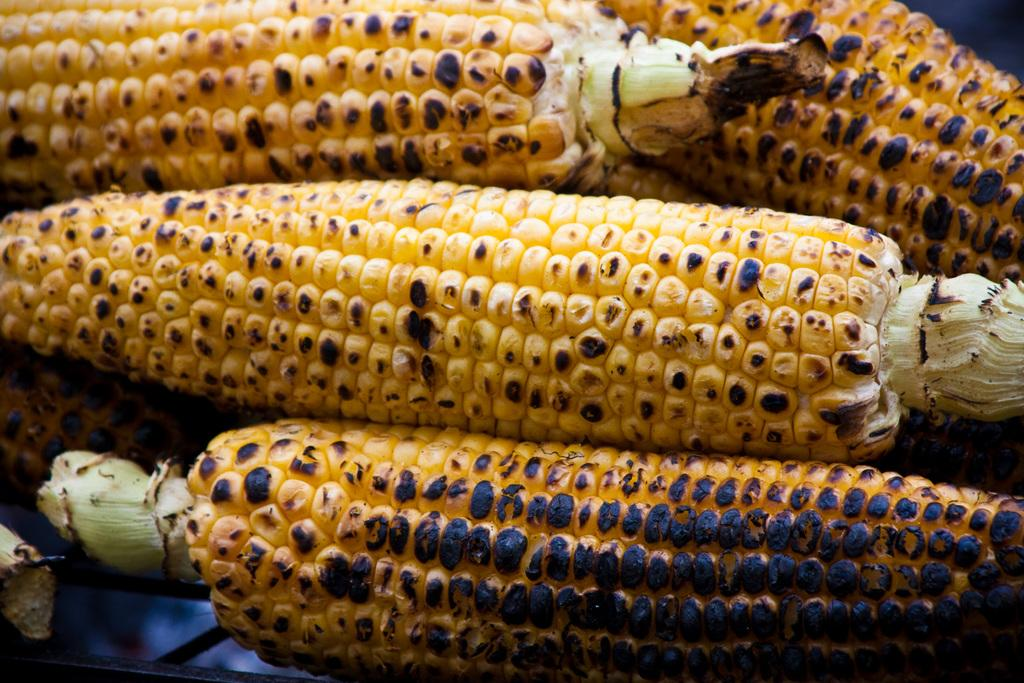What type of food is featured in the image? There is grilled corn in the image. Can you see any patches of berries growing on the earth in the image? There is no reference to patches of berries or the earth in the image; it features grilled corn. 